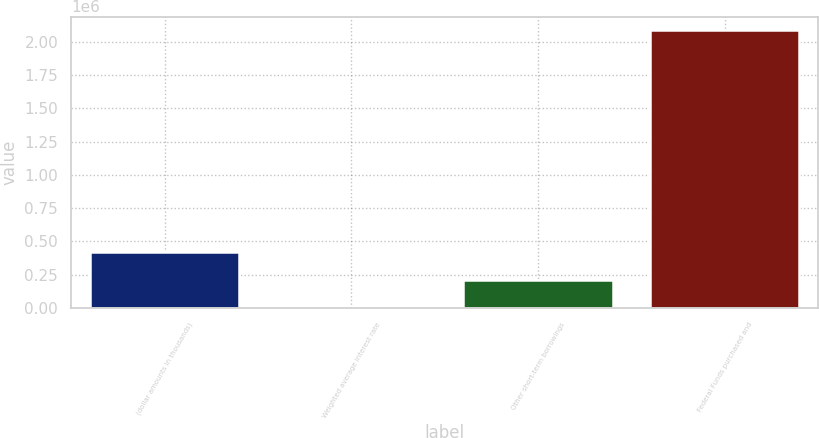Convert chart to OTSL. <chart><loc_0><loc_0><loc_500><loc_500><bar_chart><fcel>(dollar amounts in thousands)<fcel>Weighted average interest rate<fcel>Other short-term borrowings<fcel>Federal Funds purchased and<nl><fcel>416886<fcel>0.19<fcel>208443<fcel>2.08443e+06<nl></chart> 